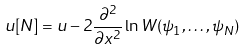Convert formula to latex. <formula><loc_0><loc_0><loc_500><loc_500>u [ N ] = u - 2 \frac { \partial ^ { 2 } } { \partial x ^ { 2 } } \ln W ( \psi _ { 1 } , \dots , \psi _ { N } )</formula> 